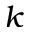<formula> <loc_0><loc_0><loc_500><loc_500>k</formula> 